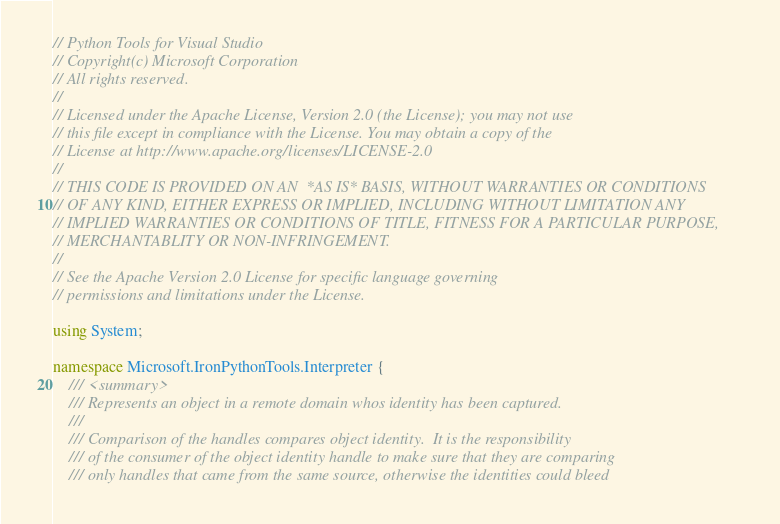<code> <loc_0><loc_0><loc_500><loc_500><_C#_>// Python Tools for Visual Studio
// Copyright(c) Microsoft Corporation
// All rights reserved.
//
// Licensed under the Apache License, Version 2.0 (the License); you may not use
// this file except in compliance with the License. You may obtain a copy of the
// License at http://www.apache.org/licenses/LICENSE-2.0
//
// THIS CODE IS PROVIDED ON AN  *AS IS* BASIS, WITHOUT WARRANTIES OR CONDITIONS
// OF ANY KIND, EITHER EXPRESS OR IMPLIED, INCLUDING WITHOUT LIMITATION ANY
// IMPLIED WARRANTIES OR CONDITIONS OF TITLE, FITNESS FOR A PARTICULAR PURPOSE,
// MERCHANTABLITY OR NON-INFRINGEMENT.
//
// See the Apache Version 2.0 License for specific language governing
// permissions and limitations under the License.

using System;

namespace Microsoft.IronPythonTools.Interpreter {
    /// <summary>
    /// Represents an object in a remote domain whos identity has been captured.
    /// 
    /// Comparison of the handles compares object identity.  It is the responsibility
    /// of the consumer of the object identity handle to make sure that they are comparing
    /// only handles that came from the same source, otherwise the identities could bleed</code> 